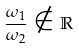<formula> <loc_0><loc_0><loc_500><loc_500>\frac { \omega _ { 1 } } { \omega _ { 2 } } \notin \mathbb { R }</formula> 